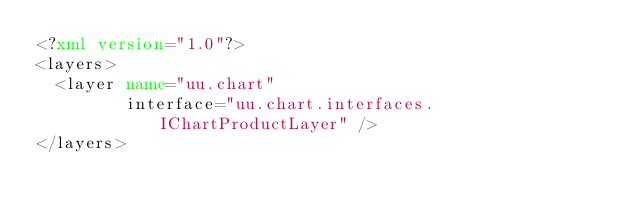<code> <loc_0><loc_0><loc_500><loc_500><_XML_><?xml version="1.0"?>    
<layers> 
  <layer name="uu.chart" 
         interface="uu.chart.interfaces.IChartProductLayer" /> 
</layers>

</code> 